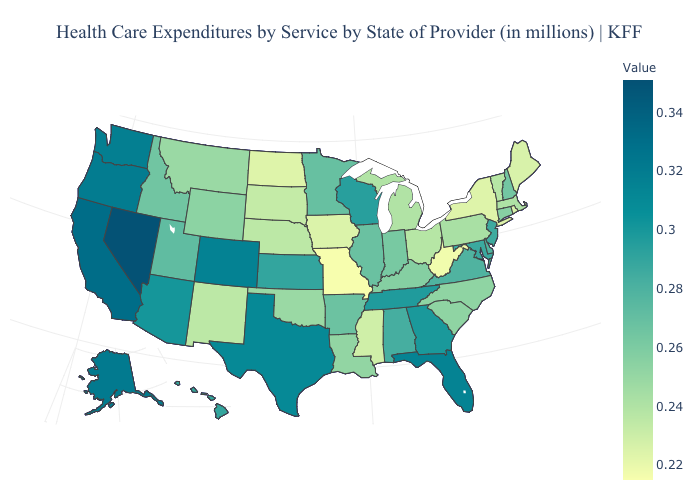Does Wisconsin have a lower value than Louisiana?
Write a very short answer. No. Does Ohio have a higher value than North Dakota?
Keep it brief. Yes. Does Mississippi have the lowest value in the South?
Quick response, please. No. Among the states that border Nebraska , which have the lowest value?
Keep it brief. Missouri. 